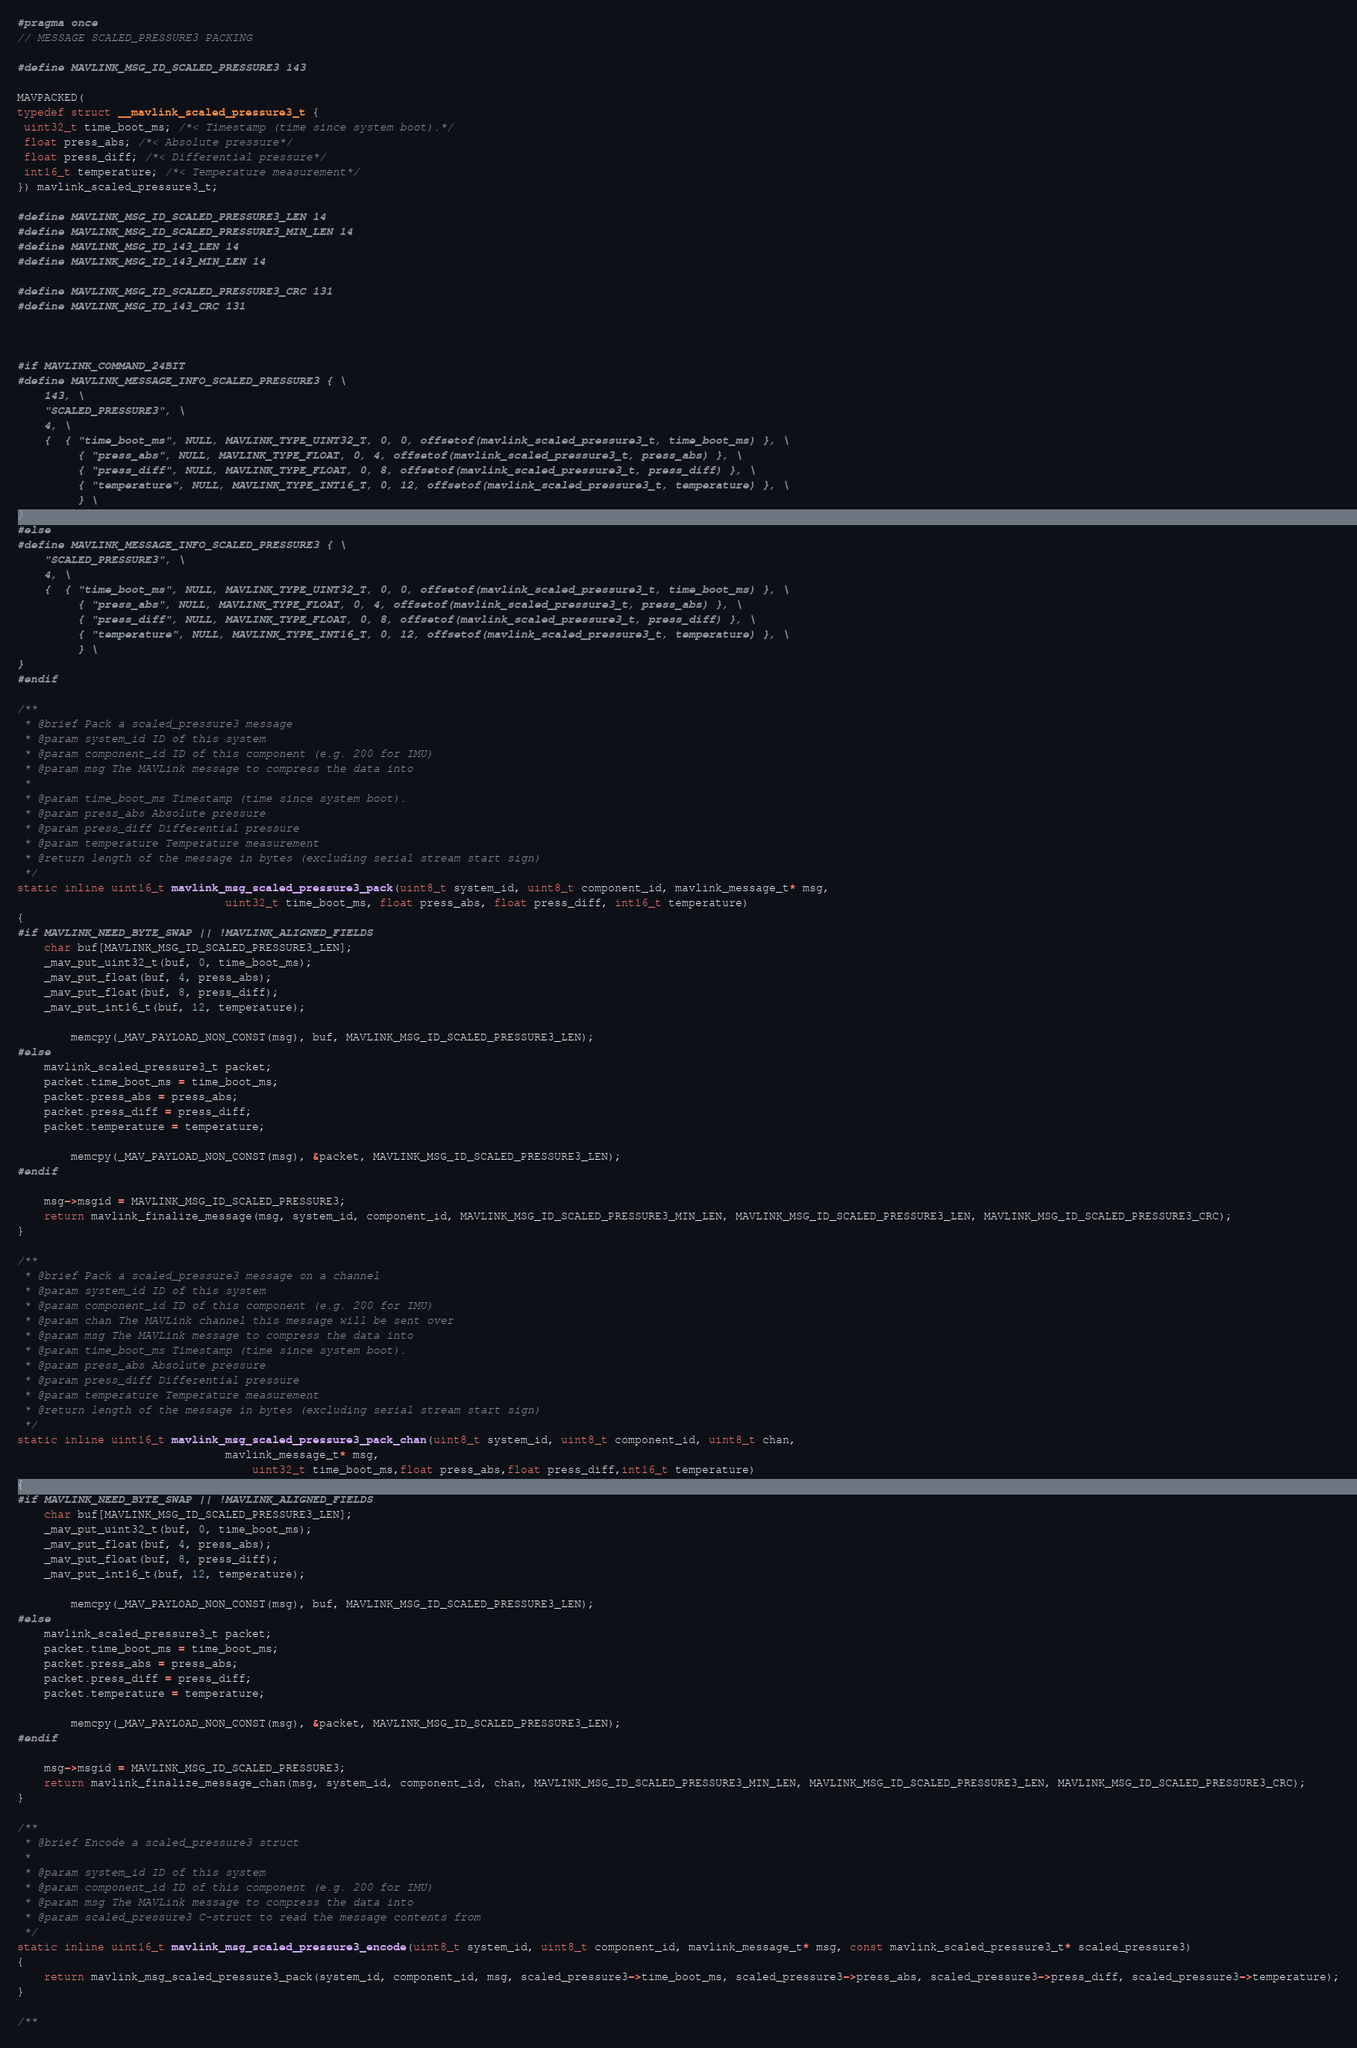<code> <loc_0><loc_0><loc_500><loc_500><_C_>#pragma once
// MESSAGE SCALED_PRESSURE3 PACKING

#define MAVLINK_MSG_ID_SCALED_PRESSURE3 143

MAVPACKED(
typedef struct __mavlink_scaled_pressure3_t {
 uint32_t time_boot_ms; /*< Timestamp (time since system boot).*/
 float press_abs; /*< Absolute pressure*/
 float press_diff; /*< Differential pressure*/
 int16_t temperature; /*< Temperature measurement*/
}) mavlink_scaled_pressure3_t;

#define MAVLINK_MSG_ID_SCALED_PRESSURE3_LEN 14
#define MAVLINK_MSG_ID_SCALED_PRESSURE3_MIN_LEN 14
#define MAVLINK_MSG_ID_143_LEN 14
#define MAVLINK_MSG_ID_143_MIN_LEN 14

#define MAVLINK_MSG_ID_SCALED_PRESSURE3_CRC 131
#define MAVLINK_MSG_ID_143_CRC 131



#if MAVLINK_COMMAND_24BIT
#define MAVLINK_MESSAGE_INFO_SCALED_PRESSURE3 { \
    143, \
    "SCALED_PRESSURE3", \
    4, \
    {  { "time_boot_ms", NULL, MAVLINK_TYPE_UINT32_T, 0, 0, offsetof(mavlink_scaled_pressure3_t, time_boot_ms) }, \
         { "press_abs", NULL, MAVLINK_TYPE_FLOAT, 0, 4, offsetof(mavlink_scaled_pressure3_t, press_abs) }, \
         { "press_diff", NULL, MAVLINK_TYPE_FLOAT, 0, 8, offsetof(mavlink_scaled_pressure3_t, press_diff) }, \
         { "temperature", NULL, MAVLINK_TYPE_INT16_T, 0, 12, offsetof(mavlink_scaled_pressure3_t, temperature) }, \
         } \
}
#else
#define MAVLINK_MESSAGE_INFO_SCALED_PRESSURE3 { \
    "SCALED_PRESSURE3", \
    4, \
    {  { "time_boot_ms", NULL, MAVLINK_TYPE_UINT32_T, 0, 0, offsetof(mavlink_scaled_pressure3_t, time_boot_ms) }, \
         { "press_abs", NULL, MAVLINK_TYPE_FLOAT, 0, 4, offsetof(mavlink_scaled_pressure3_t, press_abs) }, \
         { "press_diff", NULL, MAVLINK_TYPE_FLOAT, 0, 8, offsetof(mavlink_scaled_pressure3_t, press_diff) }, \
         { "temperature", NULL, MAVLINK_TYPE_INT16_T, 0, 12, offsetof(mavlink_scaled_pressure3_t, temperature) }, \
         } \
}
#endif

/**
 * @brief Pack a scaled_pressure3 message
 * @param system_id ID of this system
 * @param component_id ID of this component (e.g. 200 for IMU)
 * @param msg The MAVLink message to compress the data into
 *
 * @param time_boot_ms Timestamp (time since system boot).
 * @param press_abs Absolute pressure
 * @param press_diff Differential pressure
 * @param temperature Temperature measurement
 * @return length of the message in bytes (excluding serial stream start sign)
 */
static inline uint16_t mavlink_msg_scaled_pressure3_pack(uint8_t system_id, uint8_t component_id, mavlink_message_t* msg,
                               uint32_t time_boot_ms, float press_abs, float press_diff, int16_t temperature)
{
#if MAVLINK_NEED_BYTE_SWAP || !MAVLINK_ALIGNED_FIELDS
    char buf[MAVLINK_MSG_ID_SCALED_PRESSURE3_LEN];
    _mav_put_uint32_t(buf, 0, time_boot_ms);
    _mav_put_float(buf, 4, press_abs);
    _mav_put_float(buf, 8, press_diff);
    _mav_put_int16_t(buf, 12, temperature);

        memcpy(_MAV_PAYLOAD_NON_CONST(msg), buf, MAVLINK_MSG_ID_SCALED_PRESSURE3_LEN);
#else
    mavlink_scaled_pressure3_t packet;
    packet.time_boot_ms = time_boot_ms;
    packet.press_abs = press_abs;
    packet.press_diff = press_diff;
    packet.temperature = temperature;

        memcpy(_MAV_PAYLOAD_NON_CONST(msg), &packet, MAVLINK_MSG_ID_SCALED_PRESSURE3_LEN);
#endif

    msg->msgid = MAVLINK_MSG_ID_SCALED_PRESSURE3;
    return mavlink_finalize_message(msg, system_id, component_id, MAVLINK_MSG_ID_SCALED_PRESSURE3_MIN_LEN, MAVLINK_MSG_ID_SCALED_PRESSURE3_LEN, MAVLINK_MSG_ID_SCALED_PRESSURE3_CRC);
}

/**
 * @brief Pack a scaled_pressure3 message on a channel
 * @param system_id ID of this system
 * @param component_id ID of this component (e.g. 200 for IMU)
 * @param chan The MAVLink channel this message will be sent over
 * @param msg The MAVLink message to compress the data into
 * @param time_boot_ms Timestamp (time since system boot).
 * @param press_abs Absolute pressure
 * @param press_diff Differential pressure
 * @param temperature Temperature measurement
 * @return length of the message in bytes (excluding serial stream start sign)
 */
static inline uint16_t mavlink_msg_scaled_pressure3_pack_chan(uint8_t system_id, uint8_t component_id, uint8_t chan,
                               mavlink_message_t* msg,
                                   uint32_t time_boot_ms,float press_abs,float press_diff,int16_t temperature)
{
#if MAVLINK_NEED_BYTE_SWAP || !MAVLINK_ALIGNED_FIELDS
    char buf[MAVLINK_MSG_ID_SCALED_PRESSURE3_LEN];
    _mav_put_uint32_t(buf, 0, time_boot_ms);
    _mav_put_float(buf, 4, press_abs);
    _mav_put_float(buf, 8, press_diff);
    _mav_put_int16_t(buf, 12, temperature);

        memcpy(_MAV_PAYLOAD_NON_CONST(msg), buf, MAVLINK_MSG_ID_SCALED_PRESSURE3_LEN);
#else
    mavlink_scaled_pressure3_t packet;
    packet.time_boot_ms = time_boot_ms;
    packet.press_abs = press_abs;
    packet.press_diff = press_diff;
    packet.temperature = temperature;

        memcpy(_MAV_PAYLOAD_NON_CONST(msg), &packet, MAVLINK_MSG_ID_SCALED_PRESSURE3_LEN);
#endif

    msg->msgid = MAVLINK_MSG_ID_SCALED_PRESSURE3;
    return mavlink_finalize_message_chan(msg, system_id, component_id, chan, MAVLINK_MSG_ID_SCALED_PRESSURE3_MIN_LEN, MAVLINK_MSG_ID_SCALED_PRESSURE3_LEN, MAVLINK_MSG_ID_SCALED_PRESSURE3_CRC);
}

/**
 * @brief Encode a scaled_pressure3 struct
 *
 * @param system_id ID of this system
 * @param component_id ID of this component (e.g. 200 for IMU)
 * @param msg The MAVLink message to compress the data into
 * @param scaled_pressure3 C-struct to read the message contents from
 */
static inline uint16_t mavlink_msg_scaled_pressure3_encode(uint8_t system_id, uint8_t component_id, mavlink_message_t* msg, const mavlink_scaled_pressure3_t* scaled_pressure3)
{
    return mavlink_msg_scaled_pressure3_pack(system_id, component_id, msg, scaled_pressure3->time_boot_ms, scaled_pressure3->press_abs, scaled_pressure3->press_diff, scaled_pressure3->temperature);
}

/**</code> 